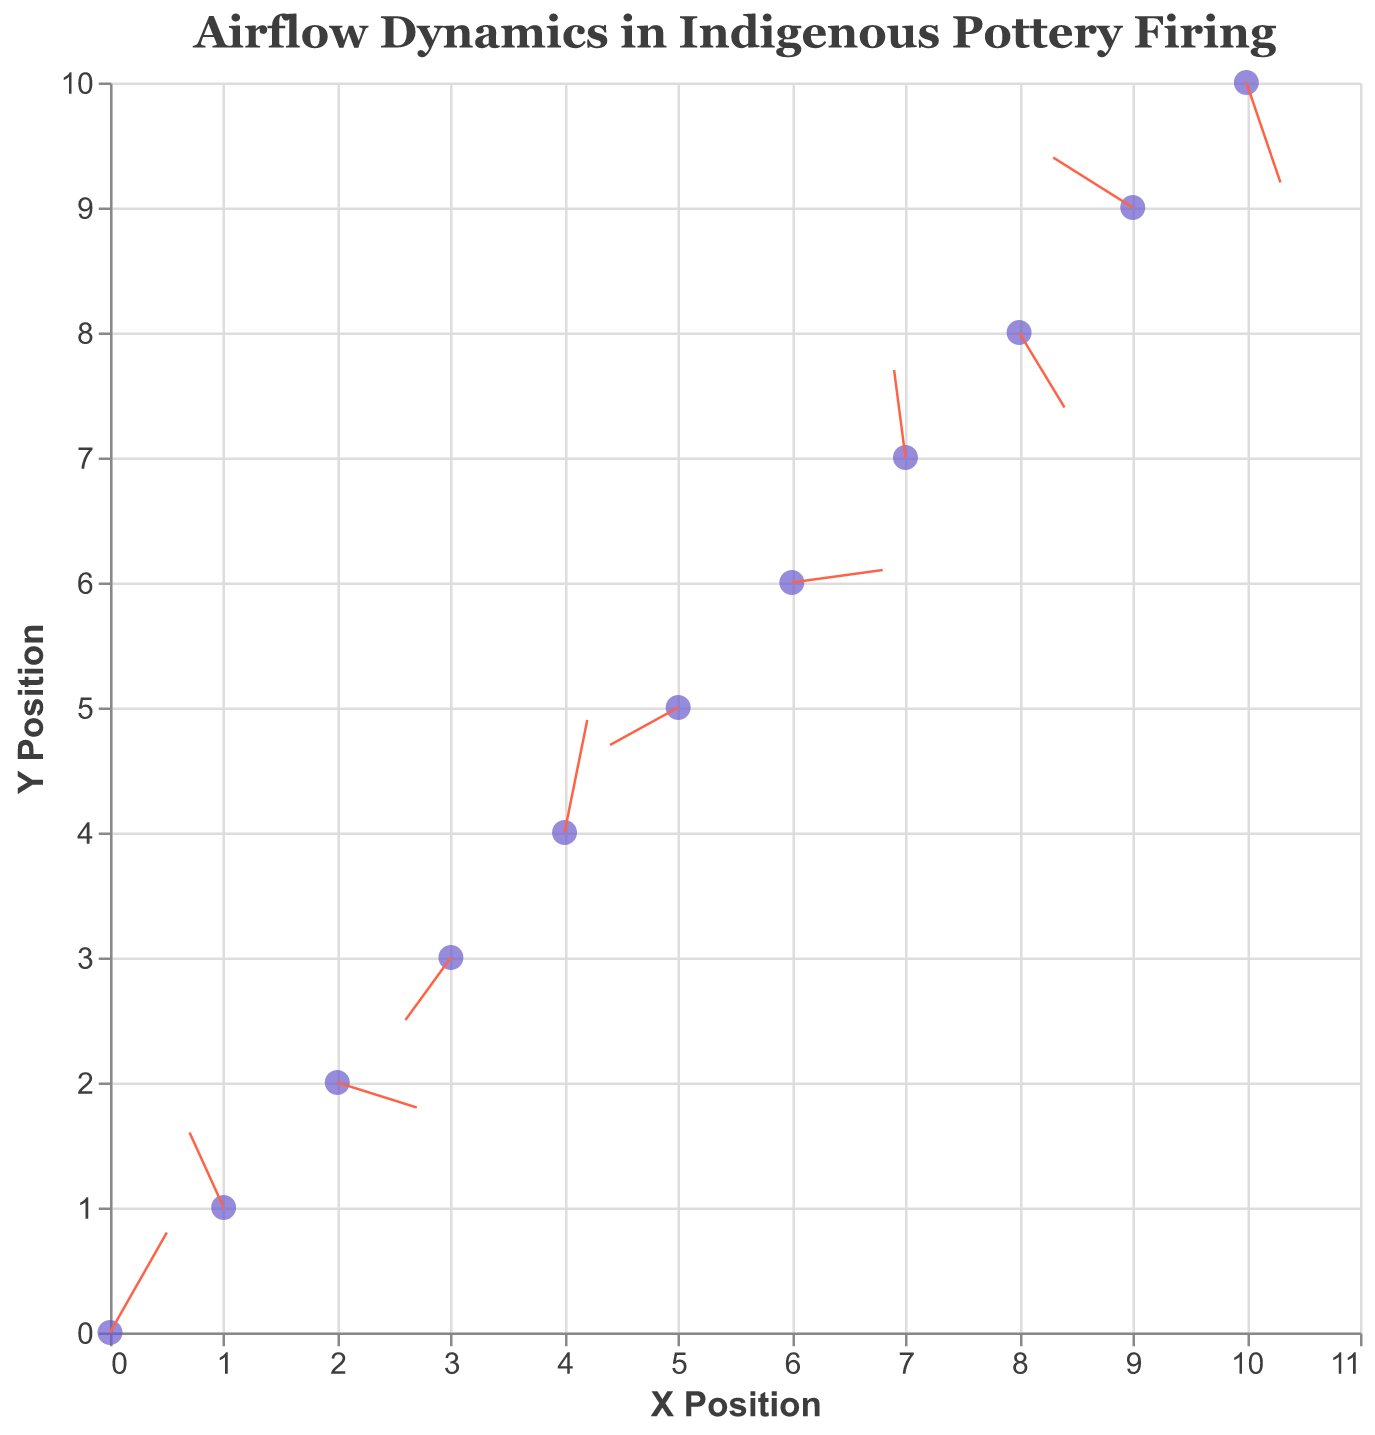What is the title of the plot? The title of the plot is displayed at the top as "Airflow Dynamics in Indigenous Pottery Firing"
Answer: Airflow Dynamics in Indigenous Pottery Firing How many data points are there in the figure? There are data points marked by filled points. Counting them reveals there are 11 data points.
Answer: 11 What are the components used to represent the airflow dynamics in the plot? The plot uses points to show the positions and arrows (rules) to represent the direction and magnitude of the airflow vectors.
Answer: Points and arrows Which data point shows the highest magnitude of airflow? By looking at the magnitude values associated with each data point, the data point (0, 0) has the highest magnitude of 0.94.
Answer: (0, 0) At which point does the airflow vector point downward most significantly? To find a downward vector, look for a negative v component. The vector at (10, 10) with v = -0.8 is the most significant downward vector.
Answer: (10, 10) What's the direction of airflow at the data point (3, 3)? The direction is determined by the u and v components. At (3, 3), the vector has u = -0.4 and v = -0.5, pointing down and left.
Answer: Down and left What is the general direction of airflow at the data point (4, 4)? The direction is given by u = 0.2 and v = 0.9, which indicates an upward and slightly right direction.
Answer: Up and right Compare the airflow magnitudes at points (1, 1) and (9, 9). Which one is larger? By comparing the magnitudes of these points, (1, 1) has 0.67 and (9, 9) has 0.81. Thus, the magnitude at (9, 9) is larger.
Answer: (9, 9) Considering the data point at (6, 6), what is the endpoint of its airflow vector? The endpoint is calculated by adding the vector components to the point coordinates: (6 + 0.8, 6 + 0.1) = (6.8, 6.1).
Answer: (6.8, 6.1) Determine if the airflow at data point (8, 8) is more horizontal or vertical. By comparing magnitudes of u and v, u = 0.4 and v = -0.6. The larger magnitude, -0.6, shows that the airflow is more vertical.
Answer: More vertical 